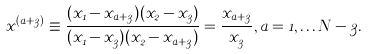Convert formula to latex. <formula><loc_0><loc_0><loc_500><loc_500>x ^ { ( a + 3 ) } \equiv \frac { ( x _ { 1 } - x _ { a + 3 } ) ( x _ { 2 } - x _ { 3 } ) } { ( x _ { 1 } - x _ { 3 } ) ( x _ { 2 } - x _ { a + 3 } ) } = \frac { x _ { a + 3 } } { x _ { 3 } } , a = 1 , \dots N - 3 .</formula> 